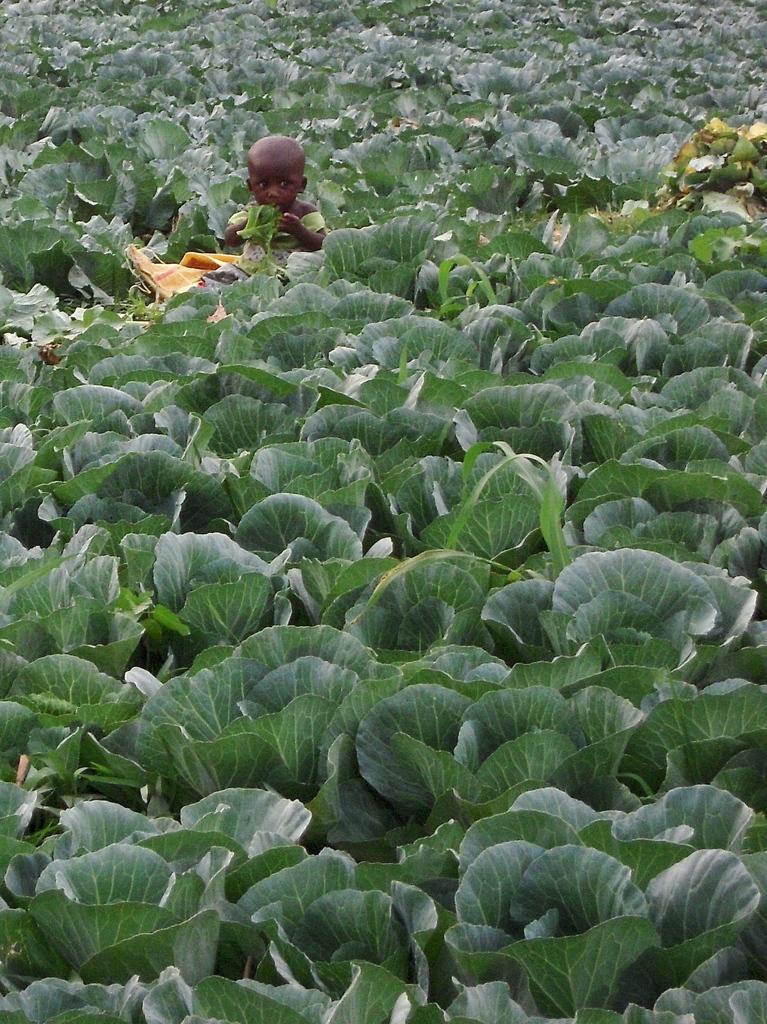Could you give a brief overview of what you see in this image? In this image we can see kid in plants. 